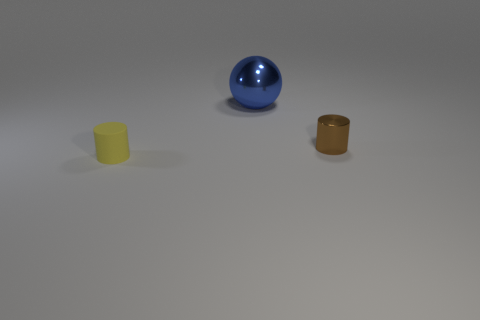Add 1 yellow matte cylinders. How many objects exist? 4 Subtract all cylinders. How many objects are left? 1 Subtract all purple rubber objects. Subtract all metallic spheres. How many objects are left? 2 Add 1 blue spheres. How many blue spheres are left? 2 Add 1 gray rubber blocks. How many gray rubber blocks exist? 1 Subtract 0 cyan cylinders. How many objects are left? 3 